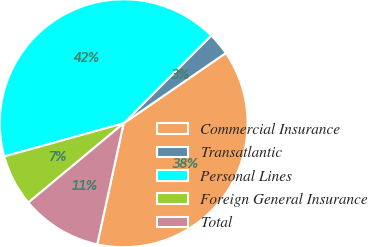<chart> <loc_0><loc_0><loc_500><loc_500><pie_chart><fcel>Commercial Insurance<fcel>Transatlantic<fcel>Personal Lines<fcel>Foreign General Insurance<fcel>Total<nl><fcel>38.01%<fcel>2.92%<fcel>41.81%<fcel>6.73%<fcel>10.53%<nl></chart> 